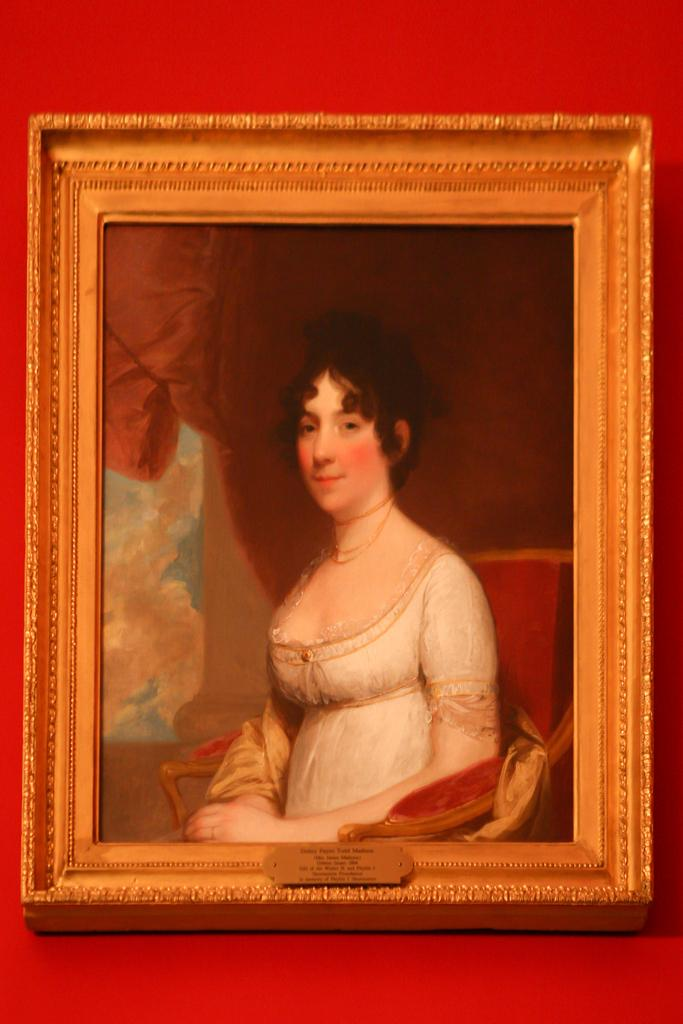What is depicted in the painting that is visible in the image? There is a painting of a woman in the image. Where is the painting located? The painting is attached to a wall. What color is the wall that the painting is attached to? The wall is red in color. Are there any dinosaurs visible in the painting? No, there are no dinosaurs present in the painting or the image. What type of street is shown in the image? There is no street visible in the image; it features a painting of a woman attached to a red wall. 